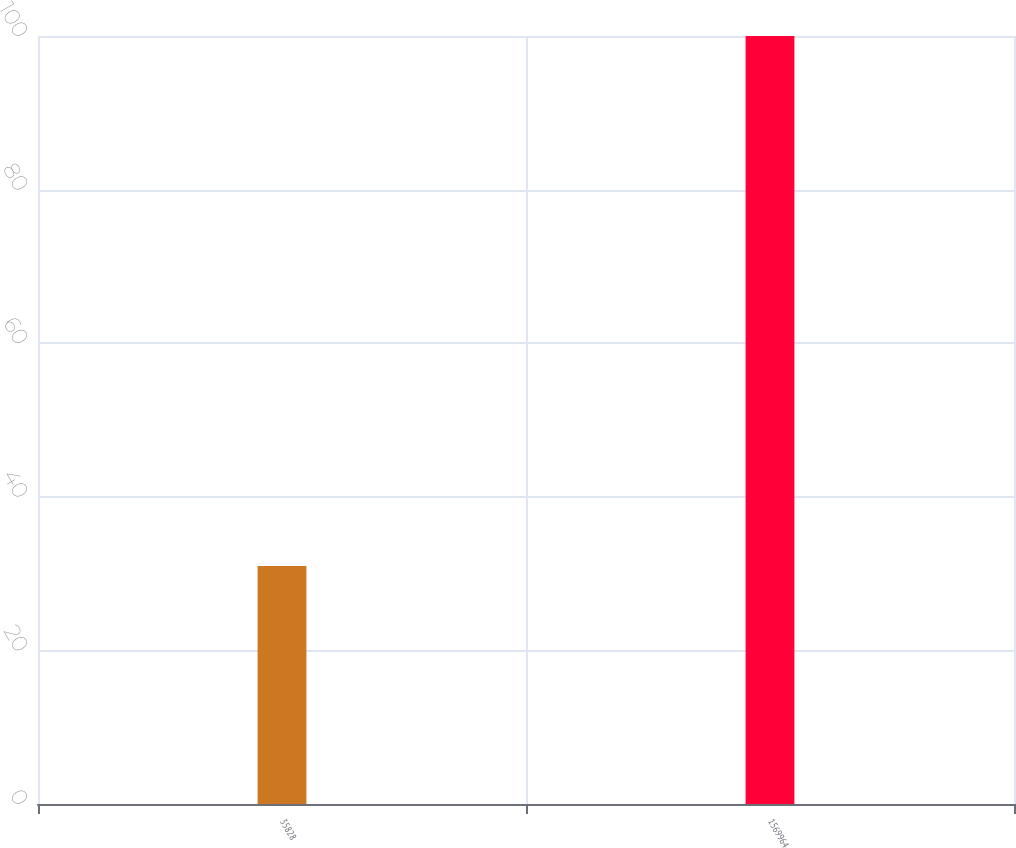<chart> <loc_0><loc_0><loc_500><loc_500><bar_chart><fcel>35828<fcel>1569964<nl><fcel>31<fcel>100<nl></chart> 